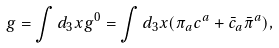<formula> <loc_0><loc_0><loc_500><loc_500>g = \int d _ { 3 } x g ^ { 0 } = \int d _ { 3 } x ( \pi _ { a } c ^ { a } + \bar { c } _ { a } \bar { \pi } ^ { a } ) ,</formula> 